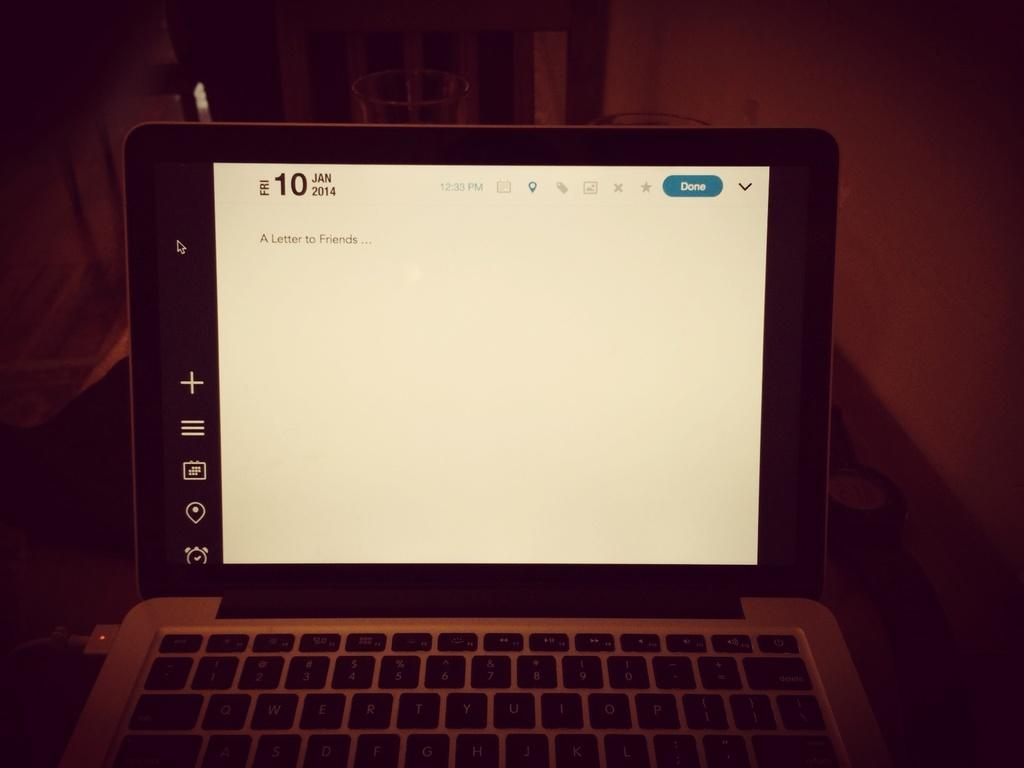<image>
Create a compact narrative representing the image presented. A laptop screen showing the date Fri Jan 10 2014. 